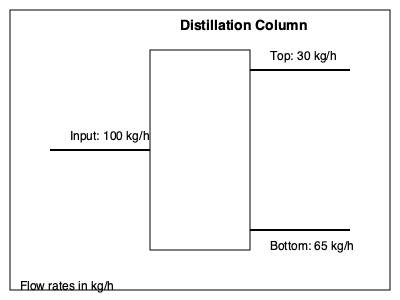Using the flow diagram of a distillation column, calculate the column's efficiency. The efficiency is defined as the ratio of the sum of output flows to the input flow, expressed as a percentage. Round your answer to the nearest whole number. To calculate the efficiency of the distillation column, we need to follow these steps:

1. Identify the input flow:
   Input flow = 100 kg/h

2. Identify the output flows:
   Top product = 30 kg/h
   Bottom product = 65 kg/h

3. Calculate the sum of output flows:
   Total output = Top product + Bottom product
   Total output = 30 kg/h + 65 kg/h = 95 kg/h

4. Calculate the efficiency using the formula:
   $$ \text{Efficiency} = \frac{\text{Sum of output flows}}{\text{Input flow}} \times 100\% $$

   $$ \text{Efficiency} = \frac{95 \text{ kg/h}}{100 \text{ kg/h}} \times 100\% = 0.95 \times 100\% = 95\% $$

5. Round the result to the nearest whole number:
   95% (no rounding needed in this case)

The efficiency of the distillation column is 95%, which indicates a high level of performance with minimal losses.
Answer: 95% 